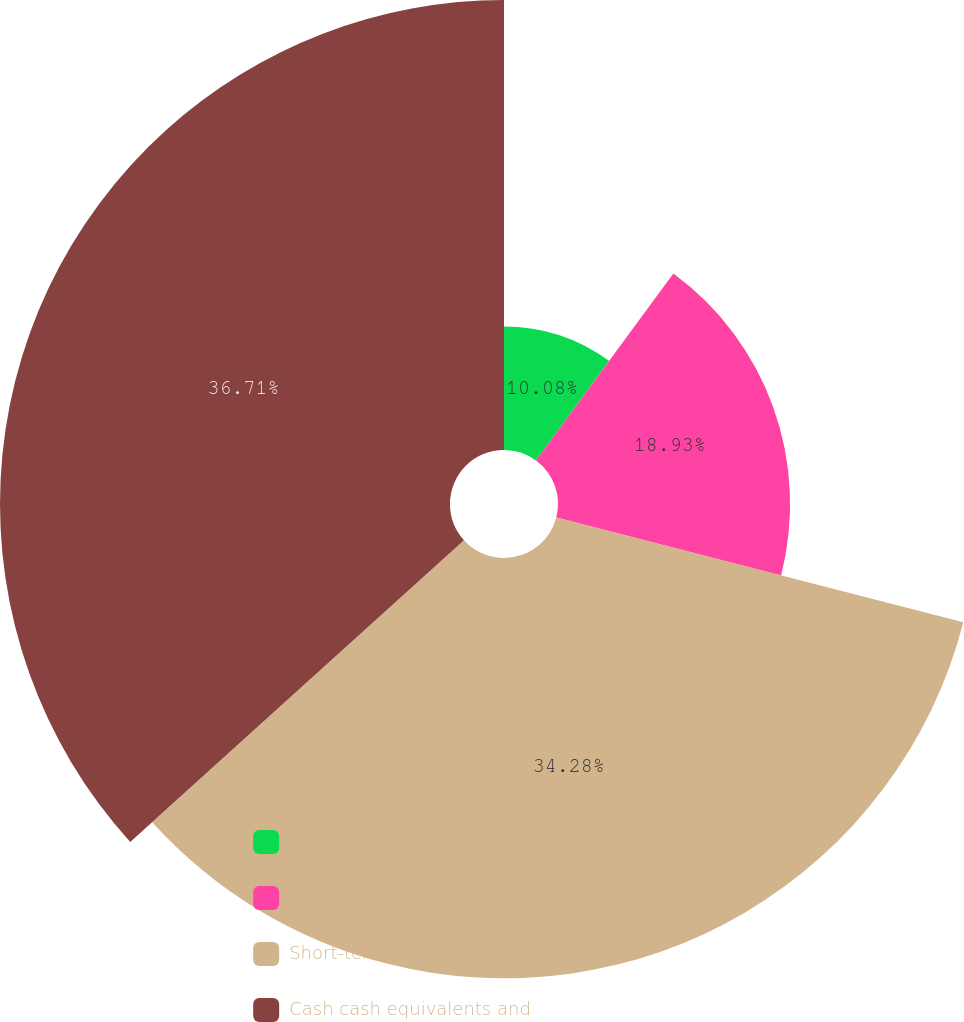Convert chart. <chart><loc_0><loc_0><loc_500><loc_500><pie_chart><fcel>US agency issues<fcel>Asset-backed bonds<fcel>Short-term investments<fcel>Cash cash equivalents and<nl><fcel>10.08%<fcel>18.93%<fcel>34.28%<fcel>36.7%<nl></chart> 